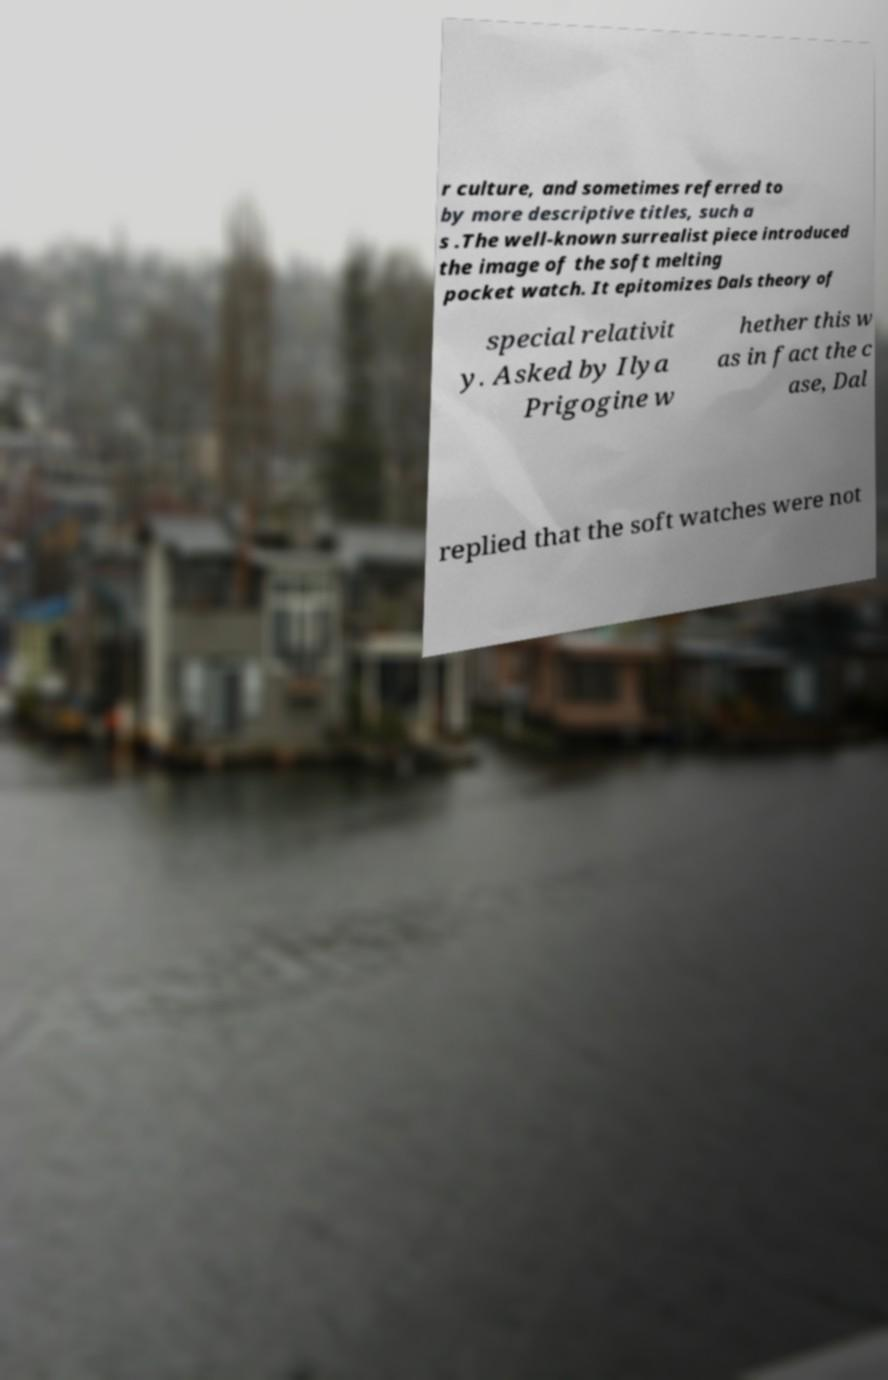Could you extract and type out the text from this image? r culture, and sometimes referred to by more descriptive titles, such a s .The well-known surrealist piece introduced the image of the soft melting pocket watch. It epitomizes Dals theory of special relativit y. Asked by Ilya Prigogine w hether this w as in fact the c ase, Dal replied that the soft watches were not 